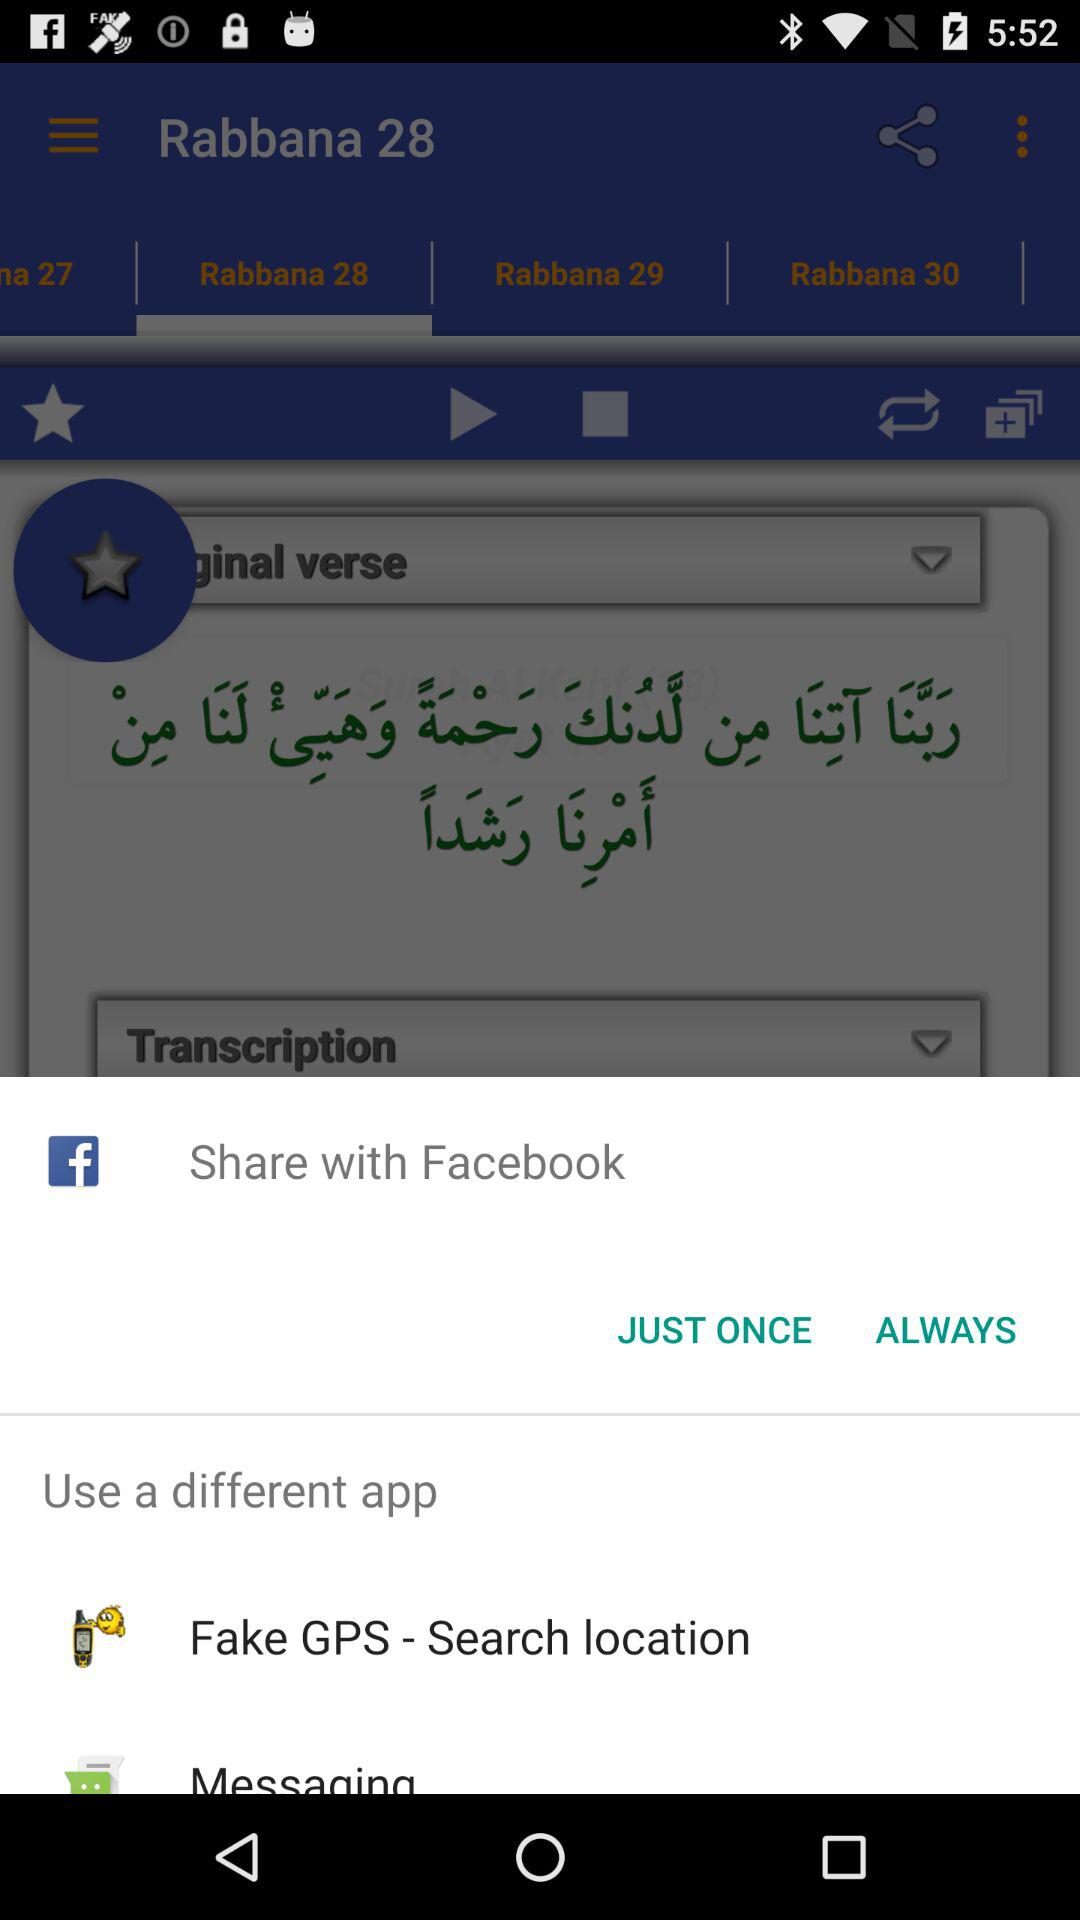What are the different applications that can be used for sharing the content? The different applications are "Facebook", "Fake GPS - Search location" and "Messaging". 